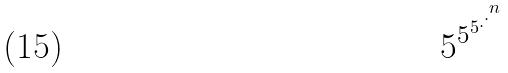Convert formula to latex. <formula><loc_0><loc_0><loc_500><loc_500>5 ^ { 5 ^ { 5 ^ { . ^ { . ^ { n } } } } }</formula> 